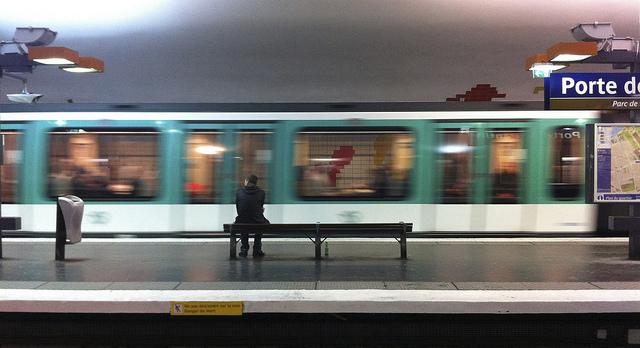What is the most likely location of this station? Please explain your reasoning. europe. The language on the sign is the language spoken in the region identified in option a. 